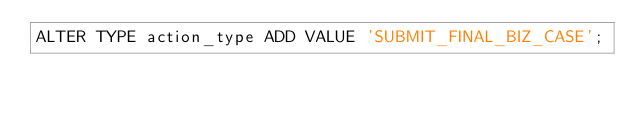Convert code to text. <code><loc_0><loc_0><loc_500><loc_500><_SQL_>ALTER TYPE action_type ADD VALUE 'SUBMIT_FINAL_BIZ_CASE';
</code> 